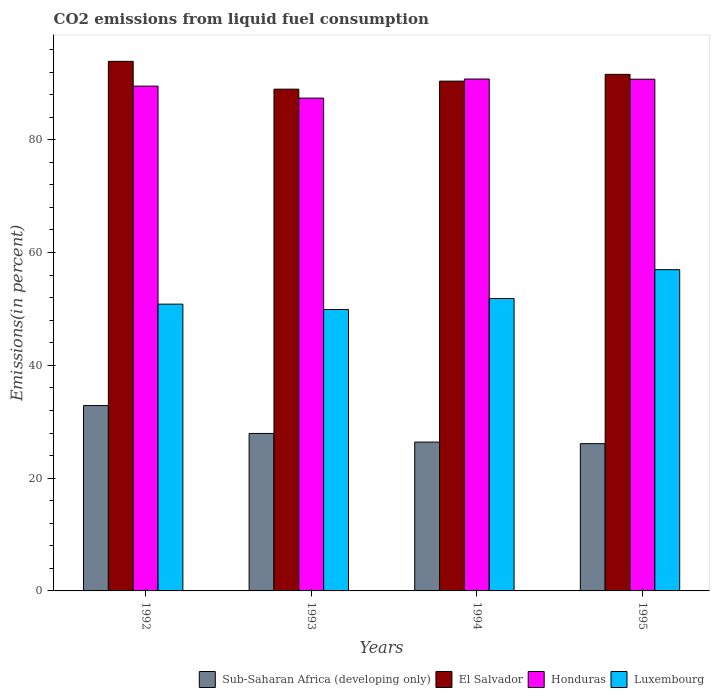How many groups of bars are there?
Give a very brief answer. 4. Are the number of bars per tick equal to the number of legend labels?
Keep it short and to the point. Yes. How many bars are there on the 4th tick from the left?
Make the answer very short. 4. In how many cases, is the number of bars for a given year not equal to the number of legend labels?
Keep it short and to the point. 0. What is the total CO2 emitted in Sub-Saharan Africa (developing only) in 1993?
Provide a short and direct response. 27.92. Across all years, what is the maximum total CO2 emitted in Honduras?
Ensure brevity in your answer.  90.77. Across all years, what is the minimum total CO2 emitted in Honduras?
Offer a terse response. 87.39. In which year was the total CO2 emitted in Sub-Saharan Africa (developing only) minimum?
Ensure brevity in your answer.  1995. What is the total total CO2 emitted in Honduras in the graph?
Your answer should be compact. 358.41. What is the difference between the total CO2 emitted in Sub-Saharan Africa (developing only) in 1994 and that in 1995?
Provide a short and direct response. 0.28. What is the difference between the total CO2 emitted in Sub-Saharan Africa (developing only) in 1992 and the total CO2 emitted in Luxembourg in 1994?
Give a very brief answer. -18.98. What is the average total CO2 emitted in Sub-Saharan Africa (developing only) per year?
Keep it short and to the point. 28.32. In the year 1992, what is the difference between the total CO2 emitted in El Salvador and total CO2 emitted in Luxembourg?
Ensure brevity in your answer.  43.05. In how many years, is the total CO2 emitted in El Salvador greater than 88 %?
Offer a terse response. 4. What is the ratio of the total CO2 emitted in Honduras in 1994 to that in 1995?
Your response must be concise. 1. Is the total CO2 emitted in Luxembourg in 1992 less than that in 1995?
Offer a very short reply. Yes. What is the difference between the highest and the second highest total CO2 emitted in Sub-Saharan Africa (developing only)?
Your answer should be compact. 4.95. What is the difference between the highest and the lowest total CO2 emitted in Honduras?
Your answer should be compact. 3.38. In how many years, is the total CO2 emitted in El Salvador greater than the average total CO2 emitted in El Salvador taken over all years?
Your answer should be compact. 2. What does the 3rd bar from the left in 1992 represents?
Your response must be concise. Honduras. What does the 2nd bar from the right in 1995 represents?
Your answer should be compact. Honduras. Is it the case that in every year, the sum of the total CO2 emitted in Honduras and total CO2 emitted in El Salvador is greater than the total CO2 emitted in Luxembourg?
Make the answer very short. Yes. How many bars are there?
Provide a short and direct response. 16. Are all the bars in the graph horizontal?
Provide a short and direct response. No. What is the difference between two consecutive major ticks on the Y-axis?
Provide a short and direct response. 20. Where does the legend appear in the graph?
Your answer should be compact. Bottom right. How many legend labels are there?
Your response must be concise. 4. What is the title of the graph?
Ensure brevity in your answer.  CO2 emissions from liquid fuel consumption. What is the label or title of the Y-axis?
Make the answer very short. Emissions(in percent). What is the Emissions(in percent) in Sub-Saharan Africa (developing only) in 1992?
Your answer should be very brief. 32.87. What is the Emissions(in percent) in El Salvador in 1992?
Your response must be concise. 93.9. What is the Emissions(in percent) of Honduras in 1992?
Give a very brief answer. 89.51. What is the Emissions(in percent) of Luxembourg in 1992?
Ensure brevity in your answer.  50.85. What is the Emissions(in percent) of Sub-Saharan Africa (developing only) in 1993?
Your response must be concise. 27.92. What is the Emissions(in percent) in El Salvador in 1993?
Your answer should be compact. 88.97. What is the Emissions(in percent) of Honduras in 1993?
Your answer should be very brief. 87.39. What is the Emissions(in percent) in Luxembourg in 1993?
Offer a very short reply. 49.9. What is the Emissions(in percent) of Sub-Saharan Africa (developing only) in 1994?
Offer a terse response. 26.39. What is the Emissions(in percent) in El Salvador in 1994?
Provide a short and direct response. 90.4. What is the Emissions(in percent) of Honduras in 1994?
Keep it short and to the point. 90.77. What is the Emissions(in percent) in Luxembourg in 1994?
Keep it short and to the point. 51.85. What is the Emissions(in percent) in Sub-Saharan Africa (developing only) in 1995?
Give a very brief answer. 26.11. What is the Emissions(in percent) of El Salvador in 1995?
Your response must be concise. 91.6. What is the Emissions(in percent) in Honduras in 1995?
Provide a short and direct response. 90.74. What is the Emissions(in percent) of Luxembourg in 1995?
Offer a very short reply. 56.97. Across all years, what is the maximum Emissions(in percent) of Sub-Saharan Africa (developing only)?
Ensure brevity in your answer.  32.87. Across all years, what is the maximum Emissions(in percent) of El Salvador?
Make the answer very short. 93.9. Across all years, what is the maximum Emissions(in percent) of Honduras?
Provide a short and direct response. 90.77. Across all years, what is the maximum Emissions(in percent) of Luxembourg?
Keep it short and to the point. 56.97. Across all years, what is the minimum Emissions(in percent) of Sub-Saharan Africa (developing only)?
Your response must be concise. 26.11. Across all years, what is the minimum Emissions(in percent) of El Salvador?
Give a very brief answer. 88.97. Across all years, what is the minimum Emissions(in percent) of Honduras?
Ensure brevity in your answer.  87.39. Across all years, what is the minimum Emissions(in percent) in Luxembourg?
Offer a very short reply. 49.9. What is the total Emissions(in percent) of Sub-Saharan Africa (developing only) in the graph?
Offer a terse response. 113.3. What is the total Emissions(in percent) of El Salvador in the graph?
Ensure brevity in your answer.  364.87. What is the total Emissions(in percent) of Honduras in the graph?
Keep it short and to the point. 358.41. What is the total Emissions(in percent) in Luxembourg in the graph?
Your answer should be very brief. 209.57. What is the difference between the Emissions(in percent) of Sub-Saharan Africa (developing only) in 1992 and that in 1993?
Provide a succinct answer. 4.95. What is the difference between the Emissions(in percent) of El Salvador in 1992 and that in 1993?
Offer a very short reply. 4.93. What is the difference between the Emissions(in percent) of Honduras in 1992 and that in 1993?
Ensure brevity in your answer.  2.12. What is the difference between the Emissions(in percent) in Luxembourg in 1992 and that in 1993?
Your answer should be very brief. 0.95. What is the difference between the Emissions(in percent) of Sub-Saharan Africa (developing only) in 1992 and that in 1994?
Offer a terse response. 6.48. What is the difference between the Emissions(in percent) of El Salvador in 1992 and that in 1994?
Your answer should be compact. 3.51. What is the difference between the Emissions(in percent) of Honduras in 1992 and that in 1994?
Give a very brief answer. -1.26. What is the difference between the Emissions(in percent) in Luxembourg in 1992 and that in 1994?
Your answer should be very brief. -1. What is the difference between the Emissions(in percent) in Sub-Saharan Africa (developing only) in 1992 and that in 1995?
Ensure brevity in your answer.  6.76. What is the difference between the Emissions(in percent) in El Salvador in 1992 and that in 1995?
Provide a succinct answer. 2.31. What is the difference between the Emissions(in percent) of Honduras in 1992 and that in 1995?
Offer a very short reply. -1.23. What is the difference between the Emissions(in percent) in Luxembourg in 1992 and that in 1995?
Offer a terse response. -6.12. What is the difference between the Emissions(in percent) of Sub-Saharan Africa (developing only) in 1993 and that in 1994?
Keep it short and to the point. 1.53. What is the difference between the Emissions(in percent) of El Salvador in 1993 and that in 1994?
Make the answer very short. -1.42. What is the difference between the Emissions(in percent) in Honduras in 1993 and that in 1994?
Ensure brevity in your answer.  -3.38. What is the difference between the Emissions(in percent) of Luxembourg in 1993 and that in 1994?
Make the answer very short. -1.96. What is the difference between the Emissions(in percent) of Sub-Saharan Africa (developing only) in 1993 and that in 1995?
Your answer should be very brief. 1.81. What is the difference between the Emissions(in percent) of El Salvador in 1993 and that in 1995?
Your response must be concise. -2.62. What is the difference between the Emissions(in percent) in Honduras in 1993 and that in 1995?
Offer a terse response. -3.35. What is the difference between the Emissions(in percent) in Luxembourg in 1993 and that in 1995?
Keep it short and to the point. -7.07. What is the difference between the Emissions(in percent) of Sub-Saharan Africa (developing only) in 1994 and that in 1995?
Your response must be concise. 0.28. What is the difference between the Emissions(in percent) in El Salvador in 1994 and that in 1995?
Give a very brief answer. -1.2. What is the difference between the Emissions(in percent) of Honduras in 1994 and that in 1995?
Make the answer very short. 0.03. What is the difference between the Emissions(in percent) of Luxembourg in 1994 and that in 1995?
Give a very brief answer. -5.11. What is the difference between the Emissions(in percent) in Sub-Saharan Africa (developing only) in 1992 and the Emissions(in percent) in El Salvador in 1993?
Your response must be concise. -56.1. What is the difference between the Emissions(in percent) in Sub-Saharan Africa (developing only) in 1992 and the Emissions(in percent) in Honduras in 1993?
Your answer should be very brief. -54.52. What is the difference between the Emissions(in percent) of Sub-Saharan Africa (developing only) in 1992 and the Emissions(in percent) of Luxembourg in 1993?
Offer a very short reply. -17.03. What is the difference between the Emissions(in percent) of El Salvador in 1992 and the Emissions(in percent) of Honduras in 1993?
Provide a short and direct response. 6.52. What is the difference between the Emissions(in percent) in El Salvador in 1992 and the Emissions(in percent) in Luxembourg in 1993?
Your response must be concise. 44.01. What is the difference between the Emissions(in percent) in Honduras in 1992 and the Emissions(in percent) in Luxembourg in 1993?
Your response must be concise. 39.61. What is the difference between the Emissions(in percent) in Sub-Saharan Africa (developing only) in 1992 and the Emissions(in percent) in El Salvador in 1994?
Your response must be concise. -57.53. What is the difference between the Emissions(in percent) in Sub-Saharan Africa (developing only) in 1992 and the Emissions(in percent) in Honduras in 1994?
Give a very brief answer. -57.9. What is the difference between the Emissions(in percent) of Sub-Saharan Africa (developing only) in 1992 and the Emissions(in percent) of Luxembourg in 1994?
Ensure brevity in your answer.  -18.98. What is the difference between the Emissions(in percent) in El Salvador in 1992 and the Emissions(in percent) in Honduras in 1994?
Your answer should be very brief. 3.13. What is the difference between the Emissions(in percent) in El Salvador in 1992 and the Emissions(in percent) in Luxembourg in 1994?
Offer a very short reply. 42.05. What is the difference between the Emissions(in percent) in Honduras in 1992 and the Emissions(in percent) in Luxembourg in 1994?
Provide a short and direct response. 37.66. What is the difference between the Emissions(in percent) of Sub-Saharan Africa (developing only) in 1992 and the Emissions(in percent) of El Salvador in 1995?
Ensure brevity in your answer.  -58.73. What is the difference between the Emissions(in percent) of Sub-Saharan Africa (developing only) in 1992 and the Emissions(in percent) of Honduras in 1995?
Your answer should be very brief. -57.87. What is the difference between the Emissions(in percent) in Sub-Saharan Africa (developing only) in 1992 and the Emissions(in percent) in Luxembourg in 1995?
Your answer should be compact. -24.1. What is the difference between the Emissions(in percent) of El Salvador in 1992 and the Emissions(in percent) of Honduras in 1995?
Keep it short and to the point. 3.17. What is the difference between the Emissions(in percent) in El Salvador in 1992 and the Emissions(in percent) in Luxembourg in 1995?
Ensure brevity in your answer.  36.94. What is the difference between the Emissions(in percent) of Honduras in 1992 and the Emissions(in percent) of Luxembourg in 1995?
Your answer should be compact. 32.54. What is the difference between the Emissions(in percent) in Sub-Saharan Africa (developing only) in 1993 and the Emissions(in percent) in El Salvador in 1994?
Provide a succinct answer. -62.47. What is the difference between the Emissions(in percent) of Sub-Saharan Africa (developing only) in 1993 and the Emissions(in percent) of Honduras in 1994?
Give a very brief answer. -62.85. What is the difference between the Emissions(in percent) in Sub-Saharan Africa (developing only) in 1993 and the Emissions(in percent) in Luxembourg in 1994?
Provide a succinct answer. -23.93. What is the difference between the Emissions(in percent) in El Salvador in 1993 and the Emissions(in percent) in Honduras in 1994?
Give a very brief answer. -1.8. What is the difference between the Emissions(in percent) of El Salvador in 1993 and the Emissions(in percent) of Luxembourg in 1994?
Offer a very short reply. 37.12. What is the difference between the Emissions(in percent) of Honduras in 1993 and the Emissions(in percent) of Luxembourg in 1994?
Keep it short and to the point. 35.53. What is the difference between the Emissions(in percent) in Sub-Saharan Africa (developing only) in 1993 and the Emissions(in percent) in El Salvador in 1995?
Ensure brevity in your answer.  -63.67. What is the difference between the Emissions(in percent) of Sub-Saharan Africa (developing only) in 1993 and the Emissions(in percent) of Honduras in 1995?
Give a very brief answer. -62.81. What is the difference between the Emissions(in percent) in Sub-Saharan Africa (developing only) in 1993 and the Emissions(in percent) in Luxembourg in 1995?
Your response must be concise. -29.04. What is the difference between the Emissions(in percent) of El Salvador in 1993 and the Emissions(in percent) of Honduras in 1995?
Your response must be concise. -1.76. What is the difference between the Emissions(in percent) of El Salvador in 1993 and the Emissions(in percent) of Luxembourg in 1995?
Give a very brief answer. 32.01. What is the difference between the Emissions(in percent) in Honduras in 1993 and the Emissions(in percent) in Luxembourg in 1995?
Make the answer very short. 30.42. What is the difference between the Emissions(in percent) in Sub-Saharan Africa (developing only) in 1994 and the Emissions(in percent) in El Salvador in 1995?
Offer a very short reply. -65.21. What is the difference between the Emissions(in percent) of Sub-Saharan Africa (developing only) in 1994 and the Emissions(in percent) of Honduras in 1995?
Your response must be concise. -64.35. What is the difference between the Emissions(in percent) in Sub-Saharan Africa (developing only) in 1994 and the Emissions(in percent) in Luxembourg in 1995?
Provide a succinct answer. -30.58. What is the difference between the Emissions(in percent) of El Salvador in 1994 and the Emissions(in percent) of Honduras in 1995?
Keep it short and to the point. -0.34. What is the difference between the Emissions(in percent) in El Salvador in 1994 and the Emissions(in percent) in Luxembourg in 1995?
Offer a terse response. 33.43. What is the difference between the Emissions(in percent) of Honduras in 1994 and the Emissions(in percent) of Luxembourg in 1995?
Give a very brief answer. 33.8. What is the average Emissions(in percent) of Sub-Saharan Africa (developing only) per year?
Your answer should be very brief. 28.32. What is the average Emissions(in percent) in El Salvador per year?
Your answer should be very brief. 91.22. What is the average Emissions(in percent) of Honduras per year?
Offer a terse response. 89.6. What is the average Emissions(in percent) of Luxembourg per year?
Your response must be concise. 52.39. In the year 1992, what is the difference between the Emissions(in percent) of Sub-Saharan Africa (developing only) and Emissions(in percent) of El Salvador?
Your answer should be compact. -61.03. In the year 1992, what is the difference between the Emissions(in percent) in Sub-Saharan Africa (developing only) and Emissions(in percent) in Honduras?
Offer a terse response. -56.64. In the year 1992, what is the difference between the Emissions(in percent) in Sub-Saharan Africa (developing only) and Emissions(in percent) in Luxembourg?
Your answer should be very brief. -17.98. In the year 1992, what is the difference between the Emissions(in percent) in El Salvador and Emissions(in percent) in Honduras?
Ensure brevity in your answer.  4.39. In the year 1992, what is the difference between the Emissions(in percent) in El Salvador and Emissions(in percent) in Luxembourg?
Provide a succinct answer. 43.05. In the year 1992, what is the difference between the Emissions(in percent) in Honduras and Emissions(in percent) in Luxembourg?
Give a very brief answer. 38.66. In the year 1993, what is the difference between the Emissions(in percent) of Sub-Saharan Africa (developing only) and Emissions(in percent) of El Salvador?
Make the answer very short. -61.05. In the year 1993, what is the difference between the Emissions(in percent) in Sub-Saharan Africa (developing only) and Emissions(in percent) in Honduras?
Provide a short and direct response. -59.46. In the year 1993, what is the difference between the Emissions(in percent) in Sub-Saharan Africa (developing only) and Emissions(in percent) in Luxembourg?
Keep it short and to the point. -21.97. In the year 1993, what is the difference between the Emissions(in percent) in El Salvador and Emissions(in percent) in Honduras?
Make the answer very short. 1.59. In the year 1993, what is the difference between the Emissions(in percent) of El Salvador and Emissions(in percent) of Luxembourg?
Offer a very short reply. 39.07. In the year 1993, what is the difference between the Emissions(in percent) in Honduras and Emissions(in percent) in Luxembourg?
Provide a succinct answer. 37.49. In the year 1994, what is the difference between the Emissions(in percent) of Sub-Saharan Africa (developing only) and Emissions(in percent) of El Salvador?
Your response must be concise. -64.01. In the year 1994, what is the difference between the Emissions(in percent) of Sub-Saharan Africa (developing only) and Emissions(in percent) of Honduras?
Your answer should be compact. -64.38. In the year 1994, what is the difference between the Emissions(in percent) in Sub-Saharan Africa (developing only) and Emissions(in percent) in Luxembourg?
Your answer should be very brief. -25.46. In the year 1994, what is the difference between the Emissions(in percent) in El Salvador and Emissions(in percent) in Honduras?
Make the answer very short. -0.37. In the year 1994, what is the difference between the Emissions(in percent) of El Salvador and Emissions(in percent) of Luxembourg?
Offer a terse response. 38.54. In the year 1994, what is the difference between the Emissions(in percent) of Honduras and Emissions(in percent) of Luxembourg?
Keep it short and to the point. 38.92. In the year 1995, what is the difference between the Emissions(in percent) in Sub-Saharan Africa (developing only) and Emissions(in percent) in El Salvador?
Your answer should be compact. -65.49. In the year 1995, what is the difference between the Emissions(in percent) of Sub-Saharan Africa (developing only) and Emissions(in percent) of Honduras?
Your response must be concise. -64.63. In the year 1995, what is the difference between the Emissions(in percent) of Sub-Saharan Africa (developing only) and Emissions(in percent) of Luxembourg?
Offer a terse response. -30.86. In the year 1995, what is the difference between the Emissions(in percent) in El Salvador and Emissions(in percent) in Honduras?
Give a very brief answer. 0.86. In the year 1995, what is the difference between the Emissions(in percent) of El Salvador and Emissions(in percent) of Luxembourg?
Offer a terse response. 34.63. In the year 1995, what is the difference between the Emissions(in percent) of Honduras and Emissions(in percent) of Luxembourg?
Offer a very short reply. 33.77. What is the ratio of the Emissions(in percent) in Sub-Saharan Africa (developing only) in 1992 to that in 1993?
Your answer should be very brief. 1.18. What is the ratio of the Emissions(in percent) in El Salvador in 1992 to that in 1993?
Offer a terse response. 1.06. What is the ratio of the Emissions(in percent) of Honduras in 1992 to that in 1993?
Offer a very short reply. 1.02. What is the ratio of the Emissions(in percent) of Luxembourg in 1992 to that in 1993?
Give a very brief answer. 1.02. What is the ratio of the Emissions(in percent) in Sub-Saharan Africa (developing only) in 1992 to that in 1994?
Your answer should be compact. 1.25. What is the ratio of the Emissions(in percent) of El Salvador in 1992 to that in 1994?
Keep it short and to the point. 1.04. What is the ratio of the Emissions(in percent) of Honduras in 1992 to that in 1994?
Make the answer very short. 0.99. What is the ratio of the Emissions(in percent) in Luxembourg in 1992 to that in 1994?
Make the answer very short. 0.98. What is the ratio of the Emissions(in percent) in Sub-Saharan Africa (developing only) in 1992 to that in 1995?
Offer a terse response. 1.26. What is the ratio of the Emissions(in percent) of El Salvador in 1992 to that in 1995?
Your answer should be compact. 1.03. What is the ratio of the Emissions(in percent) in Honduras in 1992 to that in 1995?
Provide a succinct answer. 0.99. What is the ratio of the Emissions(in percent) of Luxembourg in 1992 to that in 1995?
Offer a terse response. 0.89. What is the ratio of the Emissions(in percent) of Sub-Saharan Africa (developing only) in 1993 to that in 1994?
Provide a succinct answer. 1.06. What is the ratio of the Emissions(in percent) of El Salvador in 1993 to that in 1994?
Your answer should be compact. 0.98. What is the ratio of the Emissions(in percent) in Honduras in 1993 to that in 1994?
Provide a succinct answer. 0.96. What is the ratio of the Emissions(in percent) in Luxembourg in 1993 to that in 1994?
Provide a short and direct response. 0.96. What is the ratio of the Emissions(in percent) of Sub-Saharan Africa (developing only) in 1993 to that in 1995?
Offer a terse response. 1.07. What is the ratio of the Emissions(in percent) in El Salvador in 1993 to that in 1995?
Offer a terse response. 0.97. What is the ratio of the Emissions(in percent) of Honduras in 1993 to that in 1995?
Offer a very short reply. 0.96. What is the ratio of the Emissions(in percent) of Luxembourg in 1993 to that in 1995?
Keep it short and to the point. 0.88. What is the ratio of the Emissions(in percent) in Sub-Saharan Africa (developing only) in 1994 to that in 1995?
Offer a very short reply. 1.01. What is the ratio of the Emissions(in percent) in El Salvador in 1994 to that in 1995?
Provide a succinct answer. 0.99. What is the ratio of the Emissions(in percent) of Luxembourg in 1994 to that in 1995?
Offer a very short reply. 0.91. What is the difference between the highest and the second highest Emissions(in percent) of Sub-Saharan Africa (developing only)?
Provide a succinct answer. 4.95. What is the difference between the highest and the second highest Emissions(in percent) in El Salvador?
Provide a succinct answer. 2.31. What is the difference between the highest and the second highest Emissions(in percent) of Honduras?
Provide a short and direct response. 0.03. What is the difference between the highest and the second highest Emissions(in percent) of Luxembourg?
Ensure brevity in your answer.  5.11. What is the difference between the highest and the lowest Emissions(in percent) in Sub-Saharan Africa (developing only)?
Your response must be concise. 6.76. What is the difference between the highest and the lowest Emissions(in percent) in El Salvador?
Your answer should be compact. 4.93. What is the difference between the highest and the lowest Emissions(in percent) in Honduras?
Your answer should be compact. 3.38. What is the difference between the highest and the lowest Emissions(in percent) of Luxembourg?
Ensure brevity in your answer.  7.07. 